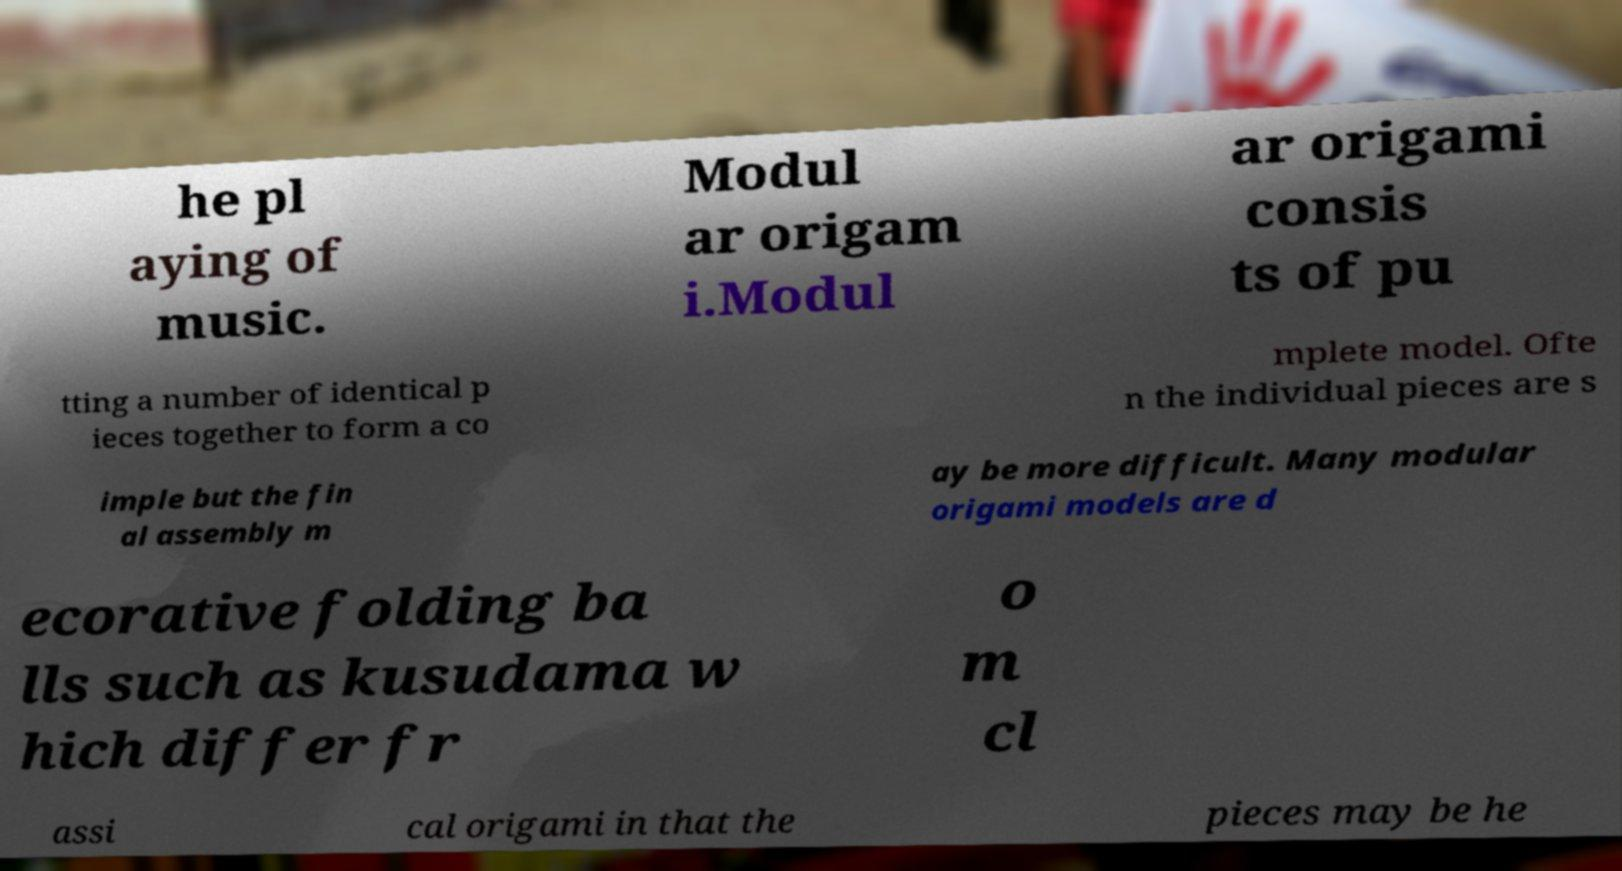For documentation purposes, I need the text within this image transcribed. Could you provide that? he pl aying of music. Modul ar origam i.Modul ar origami consis ts of pu tting a number of identical p ieces together to form a co mplete model. Ofte n the individual pieces are s imple but the fin al assembly m ay be more difficult. Many modular origami models are d ecorative folding ba lls such as kusudama w hich differ fr o m cl assi cal origami in that the pieces may be he 